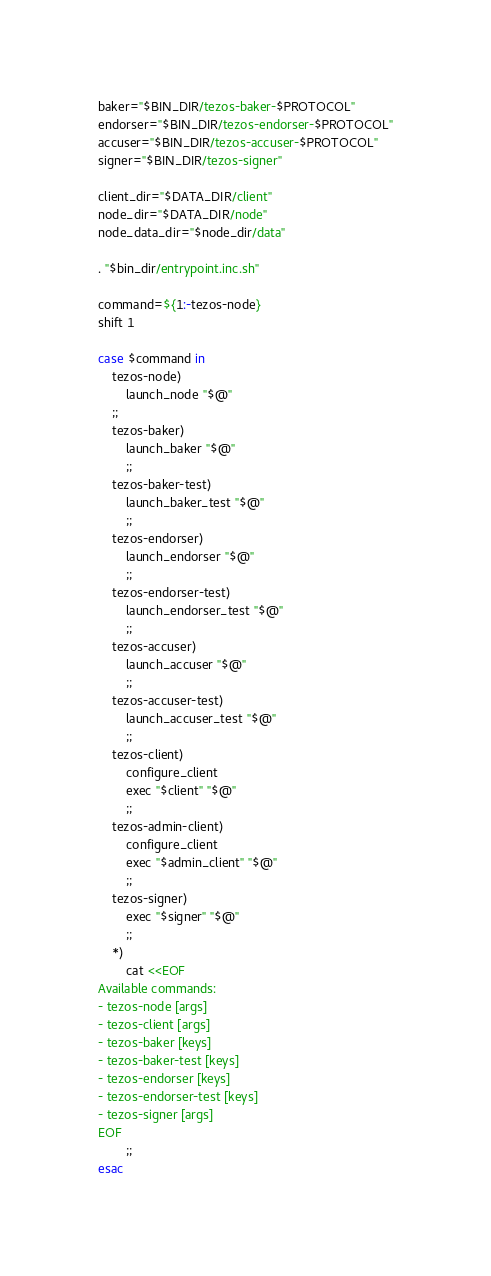<code> <loc_0><loc_0><loc_500><loc_500><_Bash_>baker="$BIN_DIR/tezos-baker-$PROTOCOL"
endorser="$BIN_DIR/tezos-endorser-$PROTOCOL"
accuser="$BIN_DIR/tezos-accuser-$PROTOCOL"
signer="$BIN_DIR/tezos-signer"

client_dir="$DATA_DIR/client"
node_dir="$DATA_DIR/node"
node_data_dir="$node_dir/data"

. "$bin_dir/entrypoint.inc.sh"

command=${1:-tezos-node}
shift 1

case $command in
    tezos-node)
        launch_node "$@"
    ;;
    tezos-baker)
        launch_baker "$@"
        ;;
    tezos-baker-test)
        launch_baker_test "$@"
        ;;
    tezos-endorser)
        launch_endorser "$@"
        ;;
    tezos-endorser-test)
        launch_endorser_test "$@"
        ;;
    tezos-accuser)
        launch_accuser "$@"
        ;;
    tezos-accuser-test)
        launch_accuser_test "$@"
        ;;
    tezos-client)
        configure_client
        exec "$client" "$@"
        ;;
    tezos-admin-client)
        configure_client
        exec "$admin_client" "$@"
        ;;
    tezos-signer)
        exec "$signer" "$@"
        ;;
    *)
        cat <<EOF
Available commands:
- tezos-node [args]
- tezos-client [args]
- tezos-baker [keys]
- tezos-baker-test [keys]
- tezos-endorser [keys]
- tezos-endorser-test [keys]
- tezos-signer [args]
EOF
        ;;
esac
</code> 